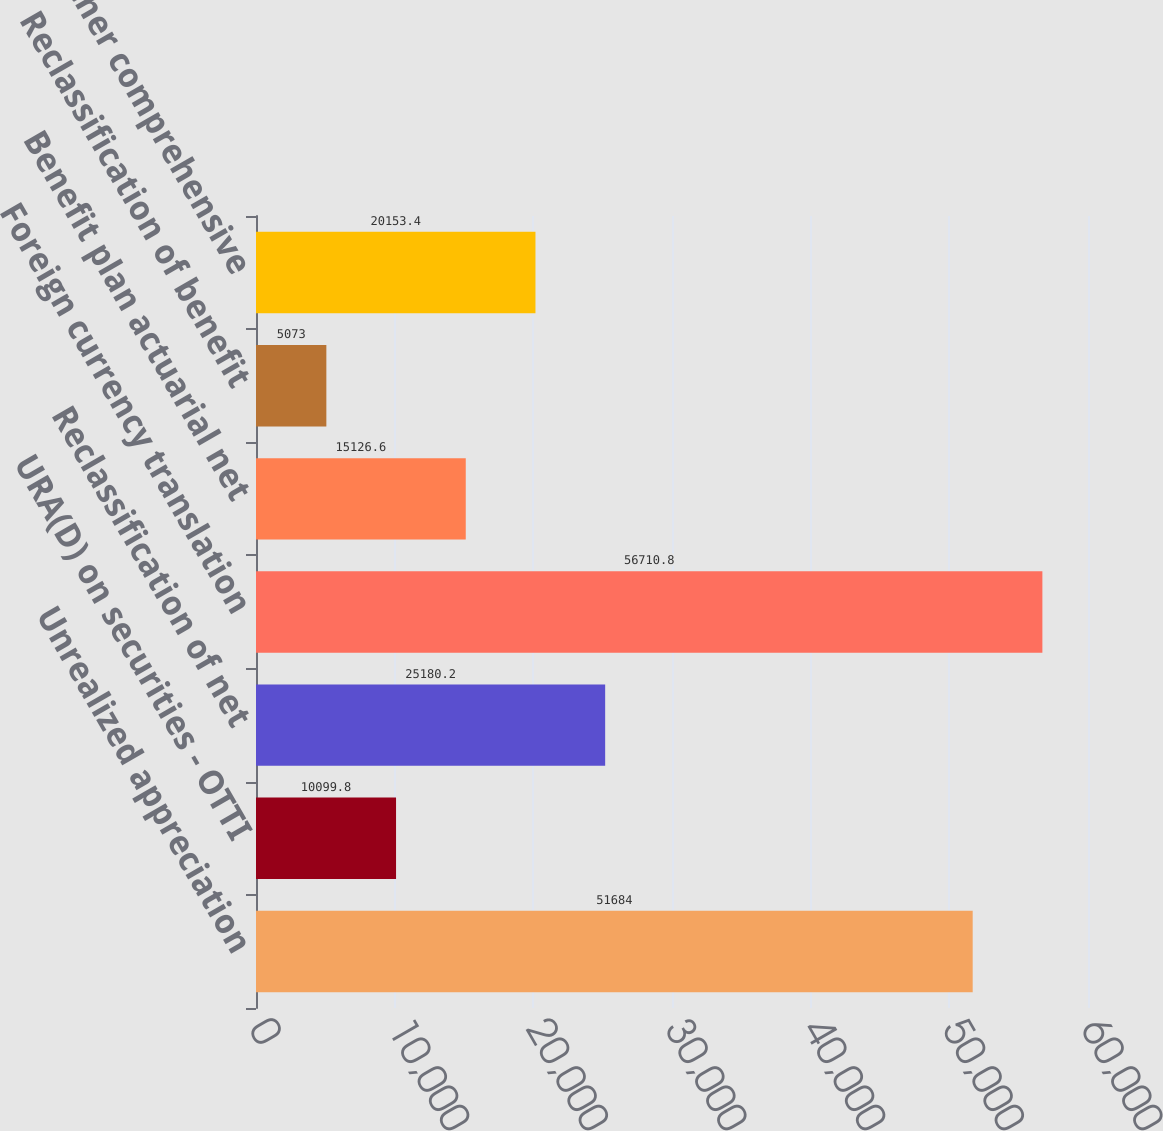<chart> <loc_0><loc_0><loc_500><loc_500><bar_chart><fcel>Unrealized appreciation<fcel>URA(D) on securities - OTTI<fcel>Reclassification of net<fcel>Foreign currency translation<fcel>Benefit plan actuarial net<fcel>Reclassification of benefit<fcel>Total other comprehensive<nl><fcel>51684<fcel>10099.8<fcel>25180.2<fcel>56710.8<fcel>15126.6<fcel>5073<fcel>20153.4<nl></chart> 